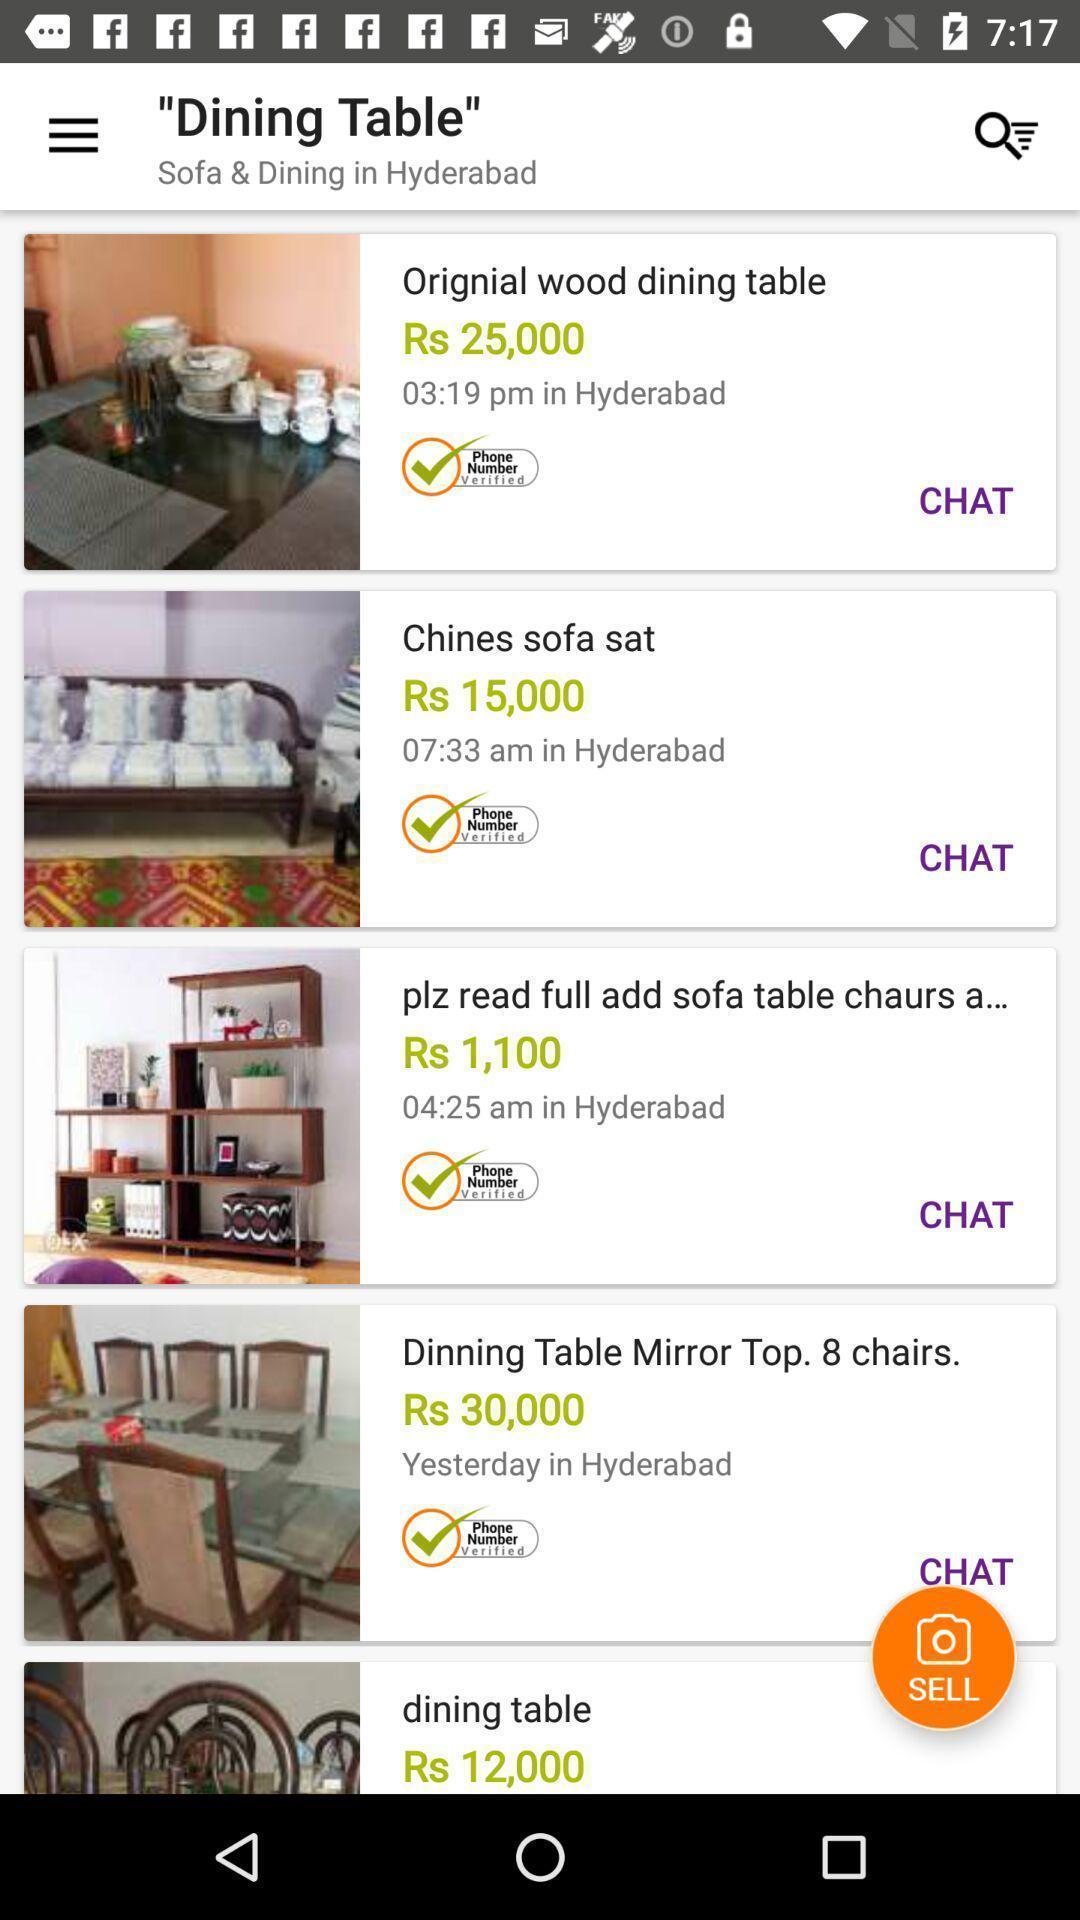Give me a narrative description of this picture. Screen page of a shopping application. 